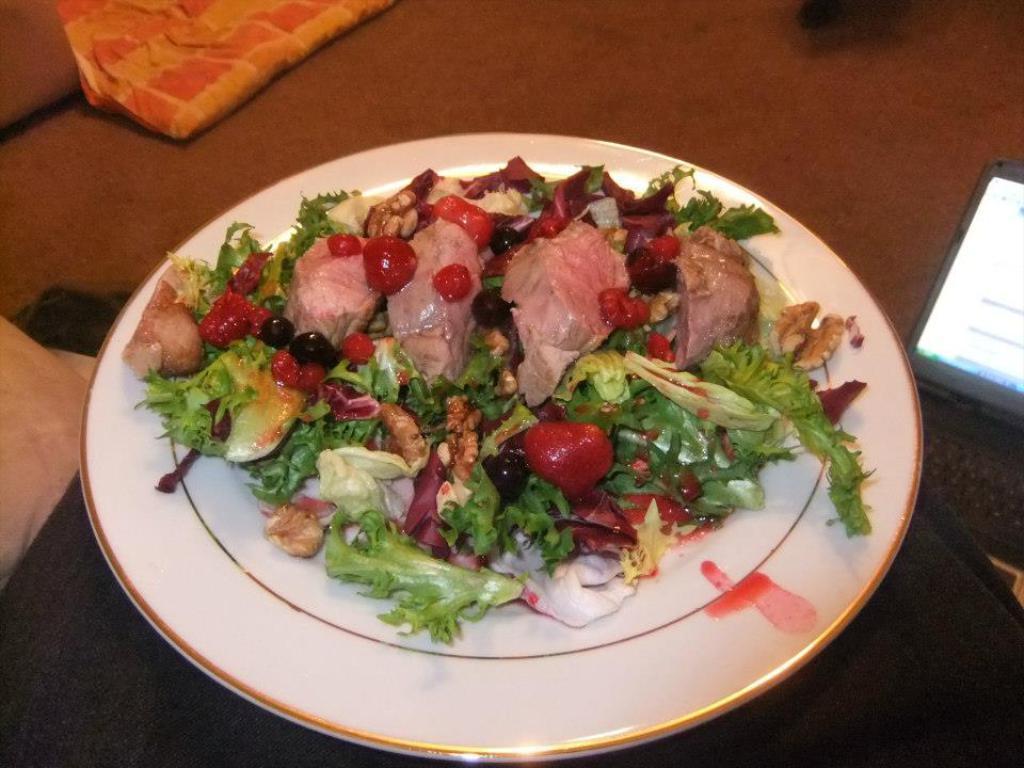Please provide a concise description of this image. In this picture I can see there is a plate of salad with meat and there are few berries in the plate. There is a laptop placed on the floor and there are few pillows and blankets. 